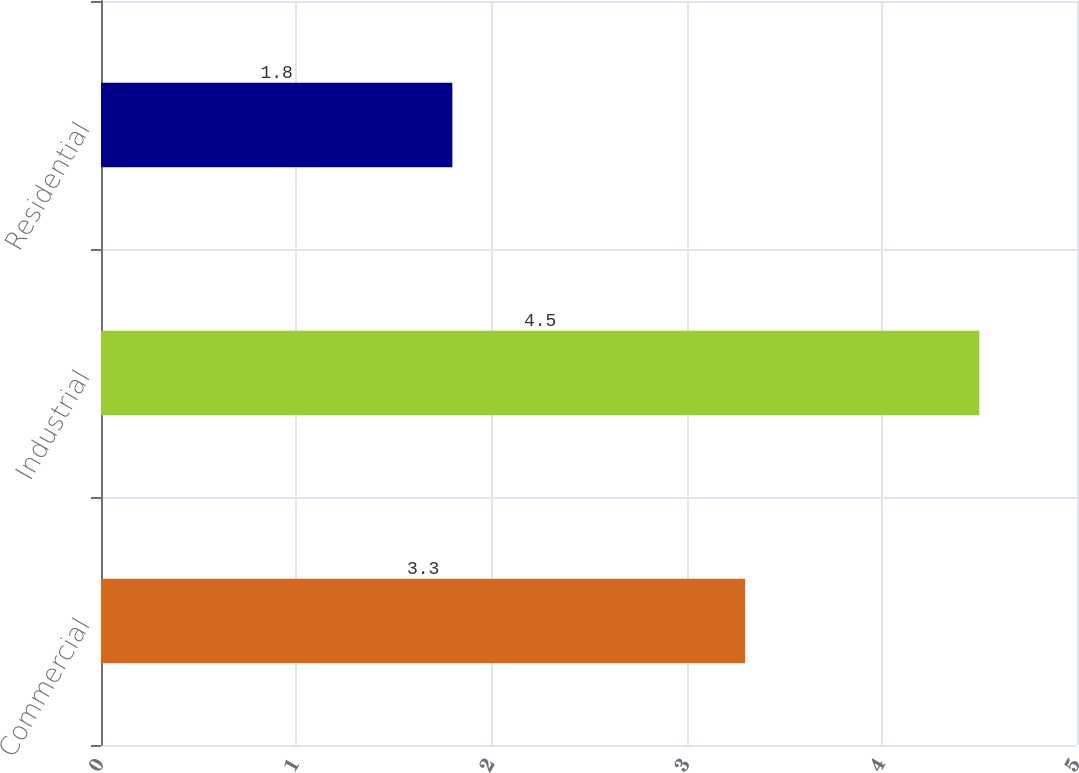<chart> <loc_0><loc_0><loc_500><loc_500><bar_chart><fcel>Commercial<fcel>Industrial<fcel>Residential<nl><fcel>3.3<fcel>4.5<fcel>1.8<nl></chart> 